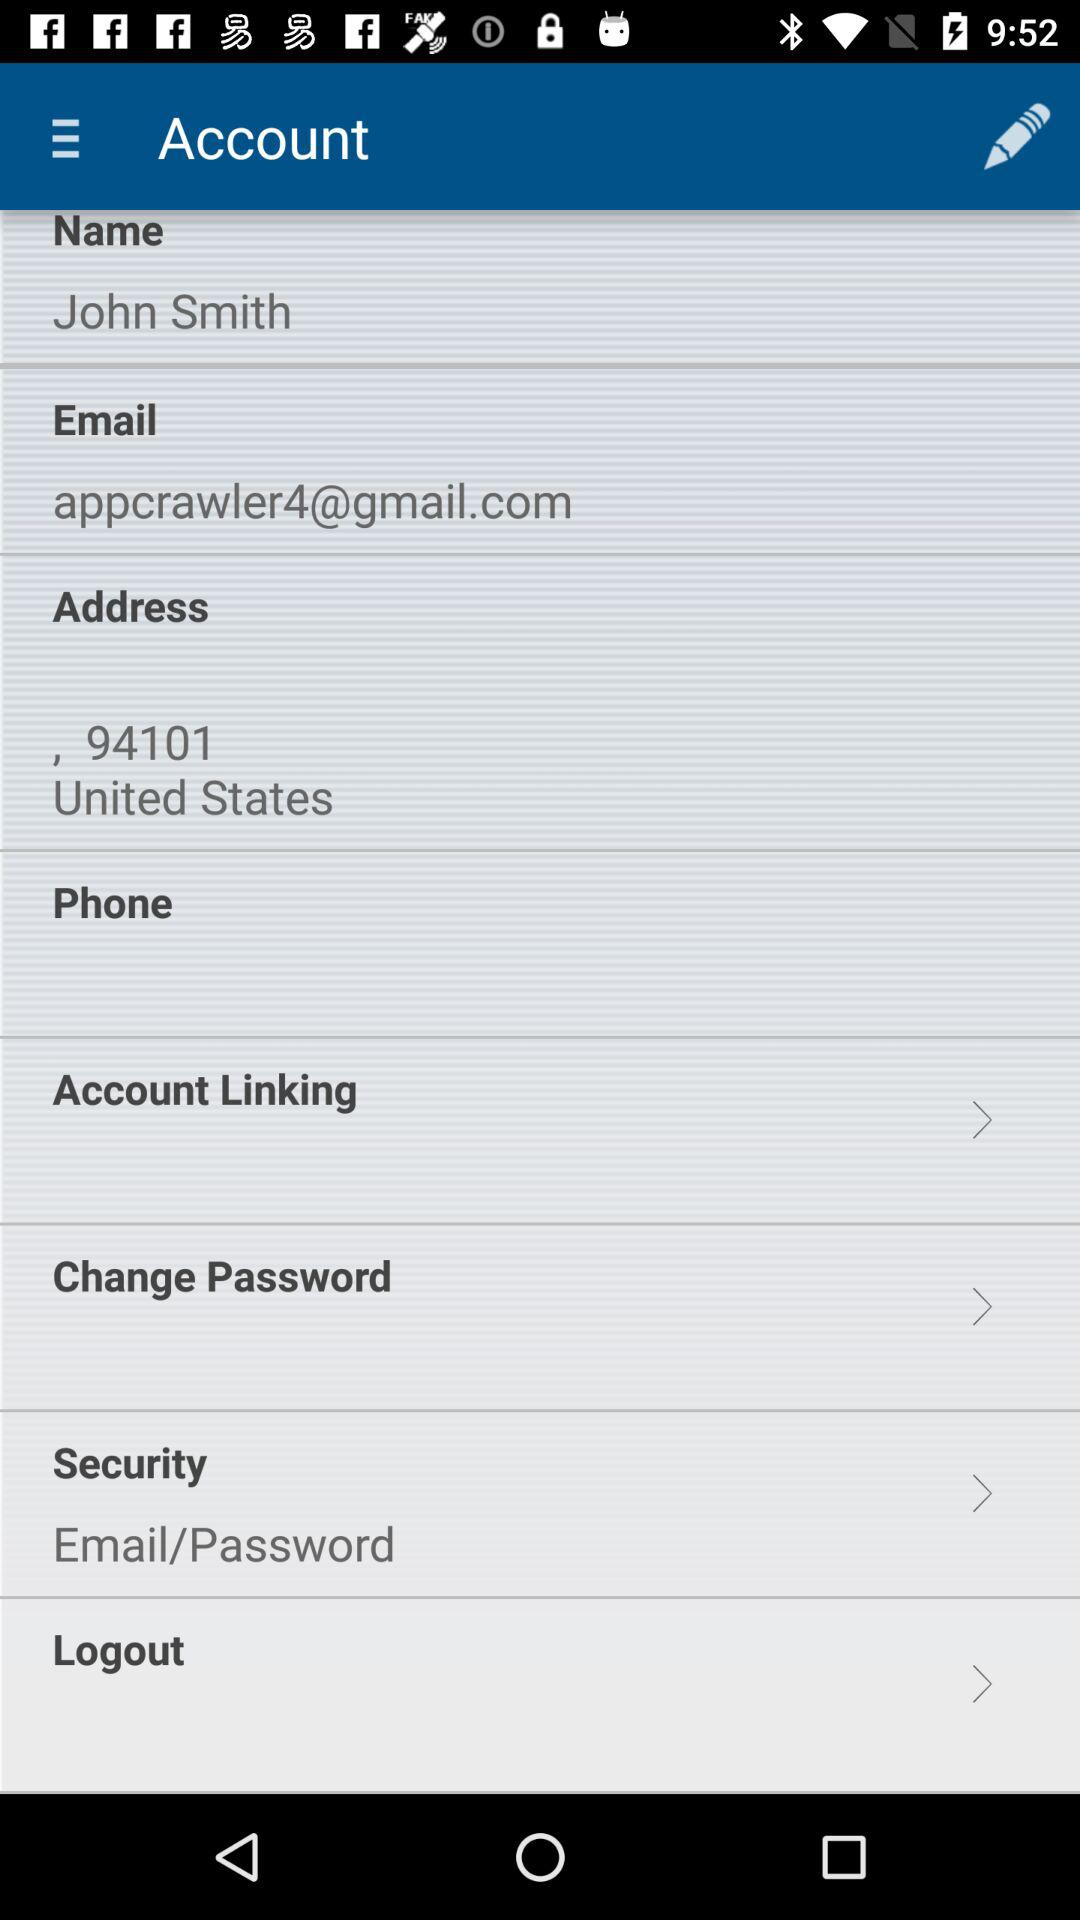What is the name of the user? The name of the user is John Smith. 